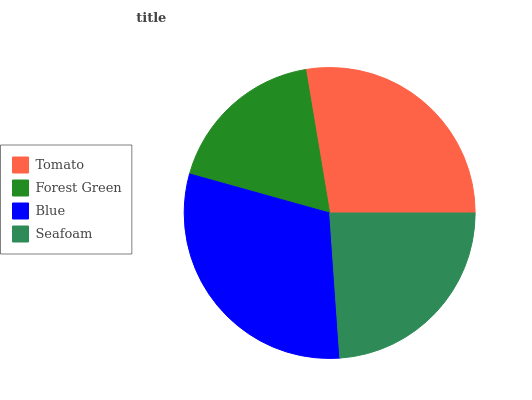Is Forest Green the minimum?
Answer yes or no. Yes. Is Blue the maximum?
Answer yes or no. Yes. Is Blue the minimum?
Answer yes or no. No. Is Forest Green the maximum?
Answer yes or no. No. Is Blue greater than Forest Green?
Answer yes or no. Yes. Is Forest Green less than Blue?
Answer yes or no. Yes. Is Forest Green greater than Blue?
Answer yes or no. No. Is Blue less than Forest Green?
Answer yes or no. No. Is Tomato the high median?
Answer yes or no. Yes. Is Seafoam the low median?
Answer yes or no. Yes. Is Forest Green the high median?
Answer yes or no. No. Is Forest Green the low median?
Answer yes or no. No. 